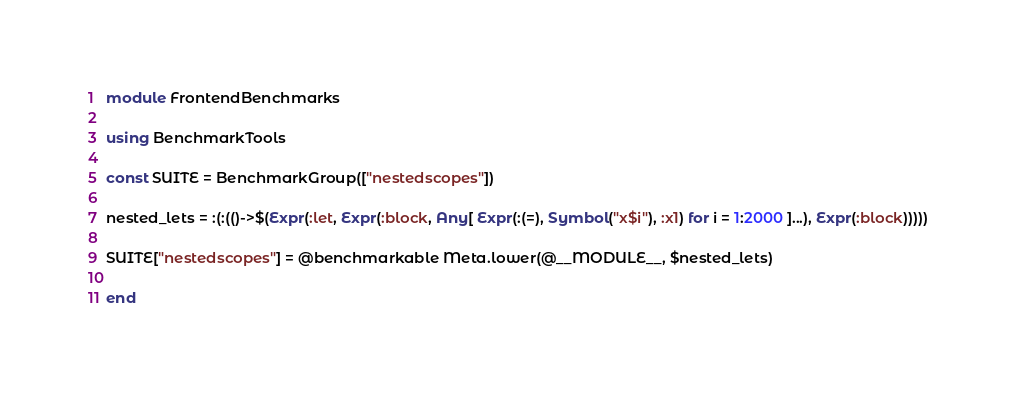<code> <loc_0><loc_0><loc_500><loc_500><_Julia_>module FrontendBenchmarks

using BenchmarkTools

const SUITE = BenchmarkGroup(["nestedscopes"])

nested_lets = :(:(()->$(Expr(:let, Expr(:block, Any[ Expr(:(=), Symbol("x$i"), :x1) for i = 1:2000 ]...), Expr(:block)))))

SUITE["nestedscopes"] = @benchmarkable Meta.lower(@__MODULE__, $nested_lets)

end
</code> 